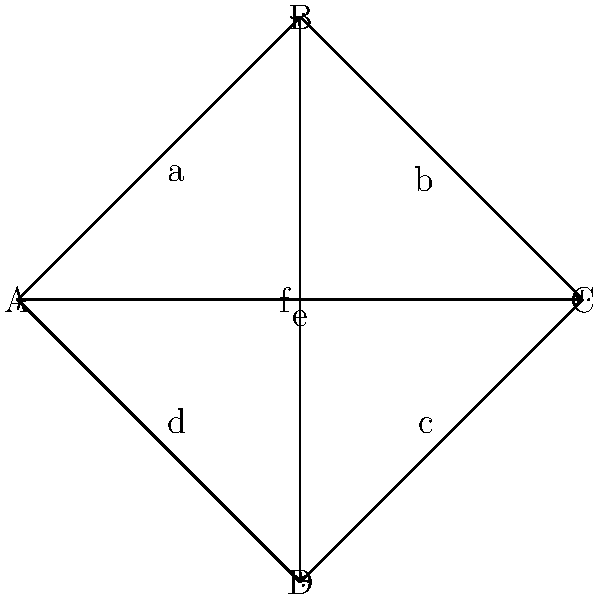In your union's voting procedure, members can choose between four different voting methods (A, B, C, D) represented by the vertices in the Cayley graph above. The edges represent possible transitions between methods. If the union starts with method A and allows three transitions, how many different voting methods could be in use after these transitions? To solve this problem, we need to follow these steps:

1. Understand the Cayley graph:
   - Vertices (A, B, C, D) represent voting methods
   - Edges (a, b, c, d, e, f) represent transitions between methods

2. Start at vertex A and count possible paths of length 3:
   - A → B → C → D
   - A → B → C → A
   - A → B → D → A
   - A → B → D → C
   - A → C → D → A
   - A → C → B → D
   - A → C → B → C

3. Identify unique end points:
   After following all possible paths of length 3 starting from A, we end up at either A, C, or D.

4. Count the number of unique end points:
   There are 3 possible voting methods that could be in use after three transitions: A, C, and D.

This analysis shows that regardless of the specific path taken, the union will end up using one of these three voting methods after three transitions.
Answer: 3 